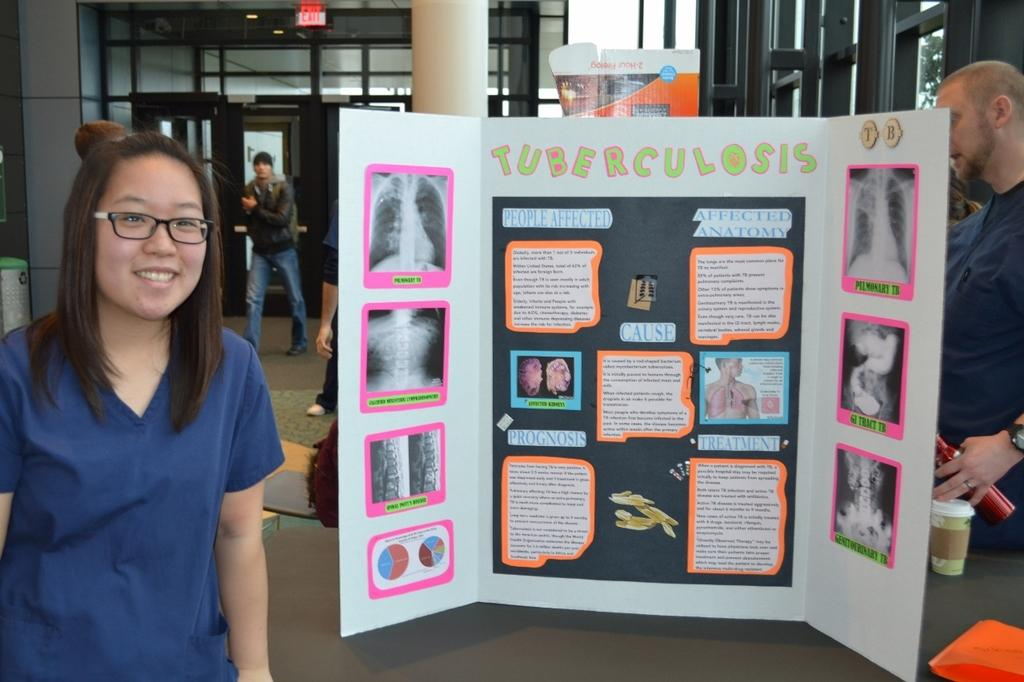Who is the main subject in the foreground of the image? There is a woman in the foreground of the image. What is located behind the woman? There is a poster behind the woman. What is behind the poster? There is a pillar behind the poster. What architectural features can be seen in the image? Windows and doors are present in the image. How many people are visible in the image? There are other people in the image besides the woman in the foreground. How many tomatoes are on the woman's head in the image? There are no tomatoes present in the image, and therefore none are on the woman's head. Can you see any chickens in the image? There are no chickens present in the image. 